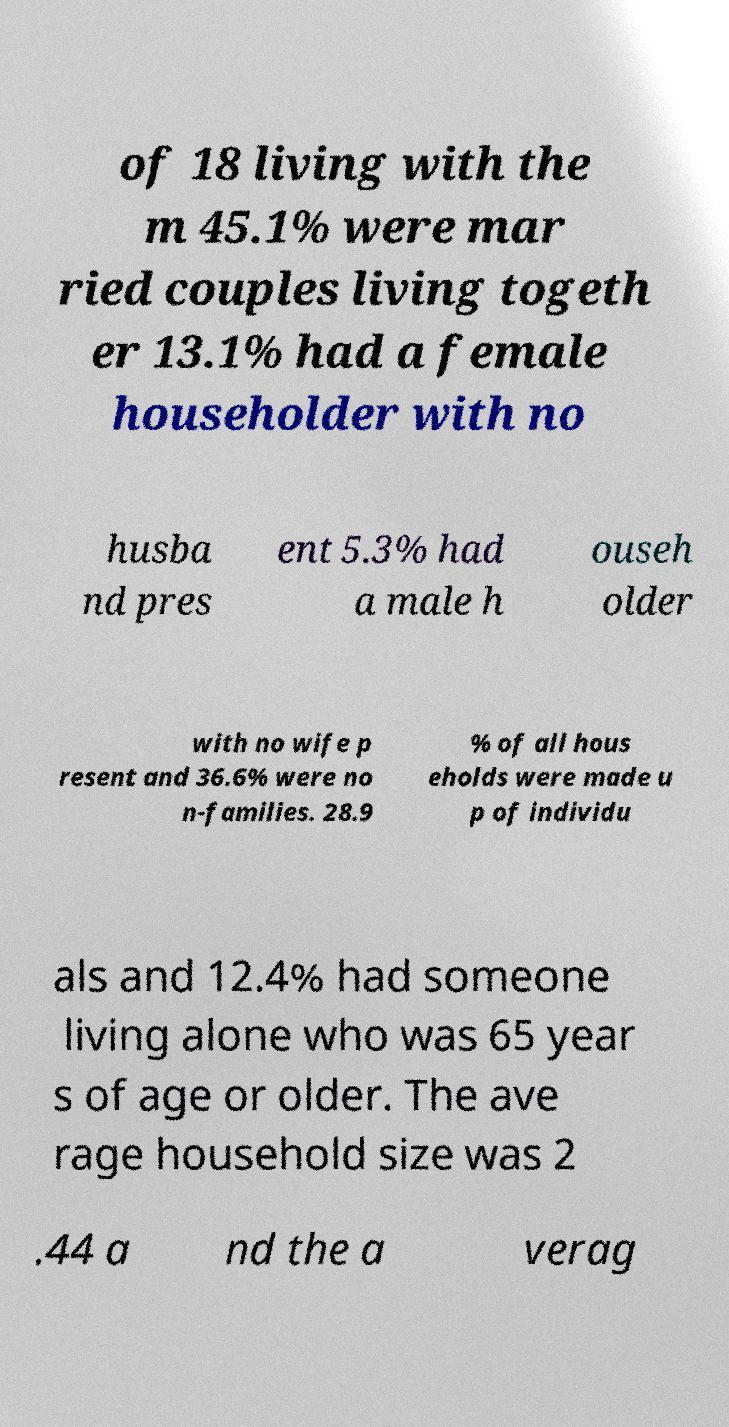Please read and relay the text visible in this image. What does it say? of 18 living with the m 45.1% were mar ried couples living togeth er 13.1% had a female householder with no husba nd pres ent 5.3% had a male h ouseh older with no wife p resent and 36.6% were no n-families. 28.9 % of all hous eholds were made u p of individu als and 12.4% had someone living alone who was 65 year s of age or older. The ave rage household size was 2 .44 a nd the a verag 